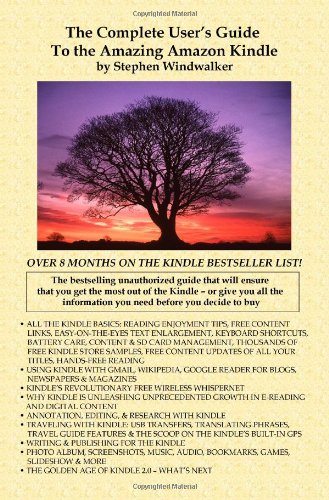Can you provide a brief summary of the Kindle features discussed in this book? This guide discusses a myriad of Kindle features such as reading enhancements, content management, and wireless connectivity, catering to both new users and experienced technology enthusiasts. How has the Kindle impacted reading habits according to the book? According to the book, the Kindle technology has transformed reading habits by offering more flexibility in when and where people can read, alongside the convenience of storing and managing extensive collections electronically. 